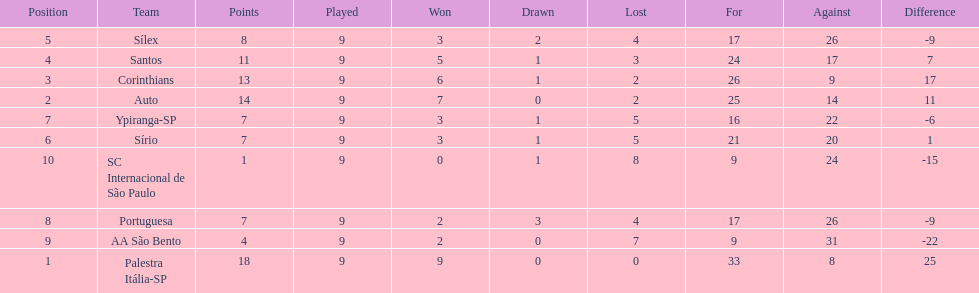Which team was the only team that was undefeated? Palestra Itália-SP. 